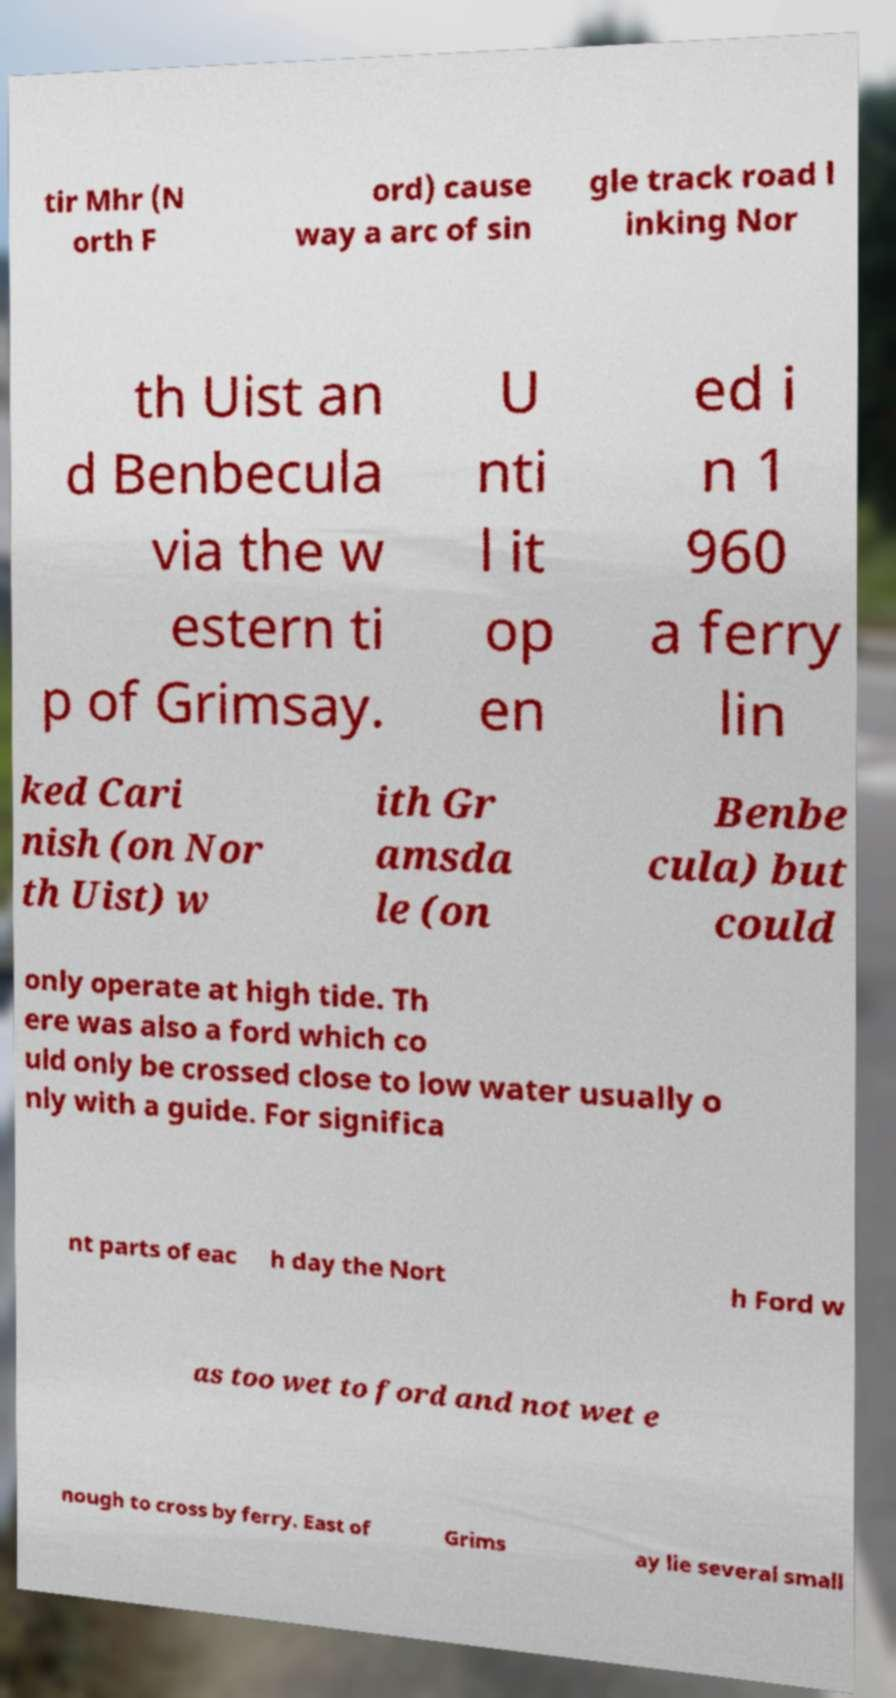Could you extract and type out the text from this image? tir Mhr (N orth F ord) cause way a arc of sin gle track road l inking Nor th Uist an d Benbecula via the w estern ti p of Grimsay. U nti l it op en ed i n 1 960 a ferry lin ked Cari nish (on Nor th Uist) w ith Gr amsda le (on Benbe cula) but could only operate at high tide. Th ere was also a ford which co uld only be crossed close to low water usually o nly with a guide. For significa nt parts of eac h day the Nort h Ford w as too wet to ford and not wet e nough to cross by ferry. East of Grims ay lie several small 